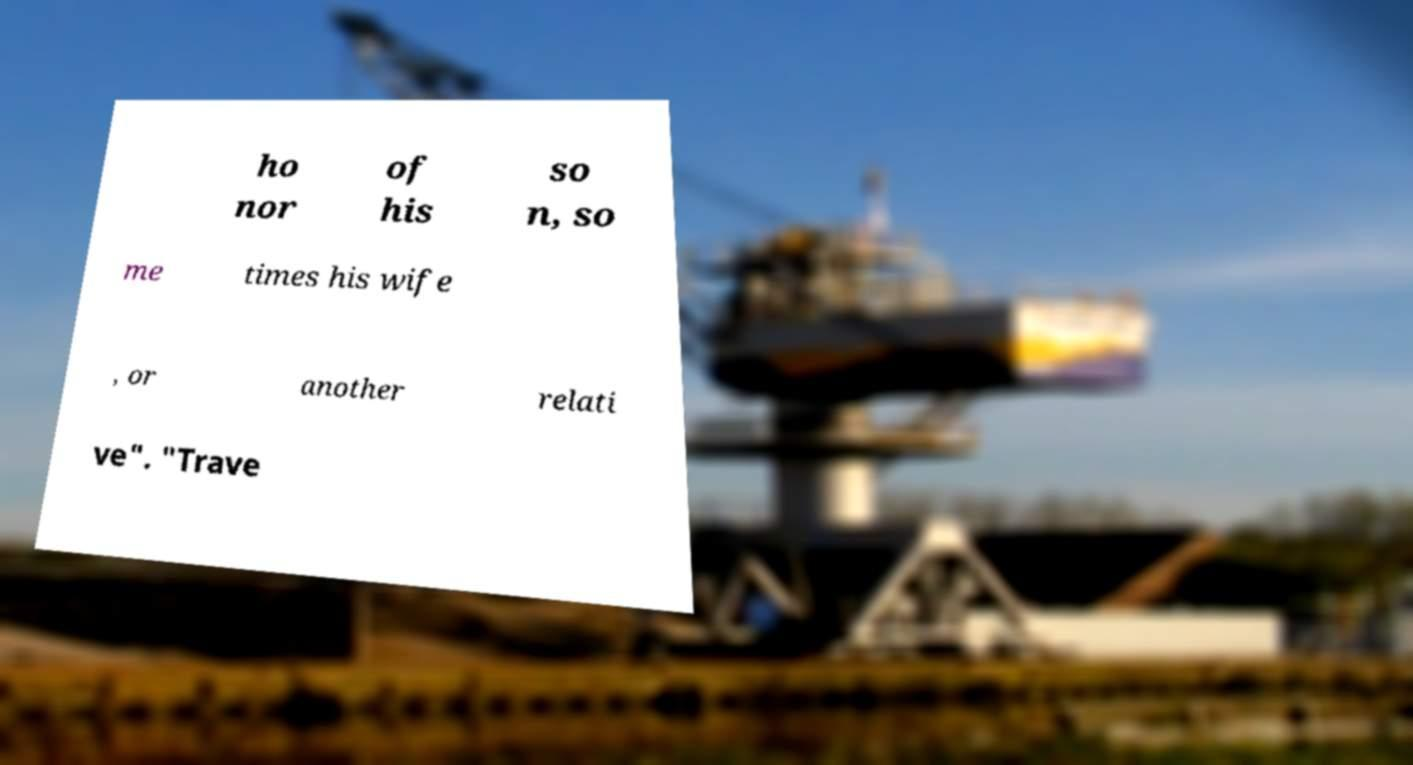For documentation purposes, I need the text within this image transcribed. Could you provide that? ho nor of his so n, so me times his wife , or another relati ve". "Trave 